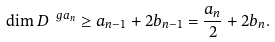Convert formula to latex. <formula><loc_0><loc_0><loc_500><loc_500>\dim D ^ { \ g a _ { n } } \geq a _ { n - 1 } + 2 b _ { n - 1 } = \frac { a _ { n } } { 2 } + 2 b _ { n } .</formula> 